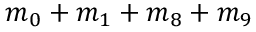Convert formula to latex. <formula><loc_0><loc_0><loc_500><loc_500>m _ { 0 } + m _ { 1 } + m _ { 8 } + m _ { 9 }</formula> 